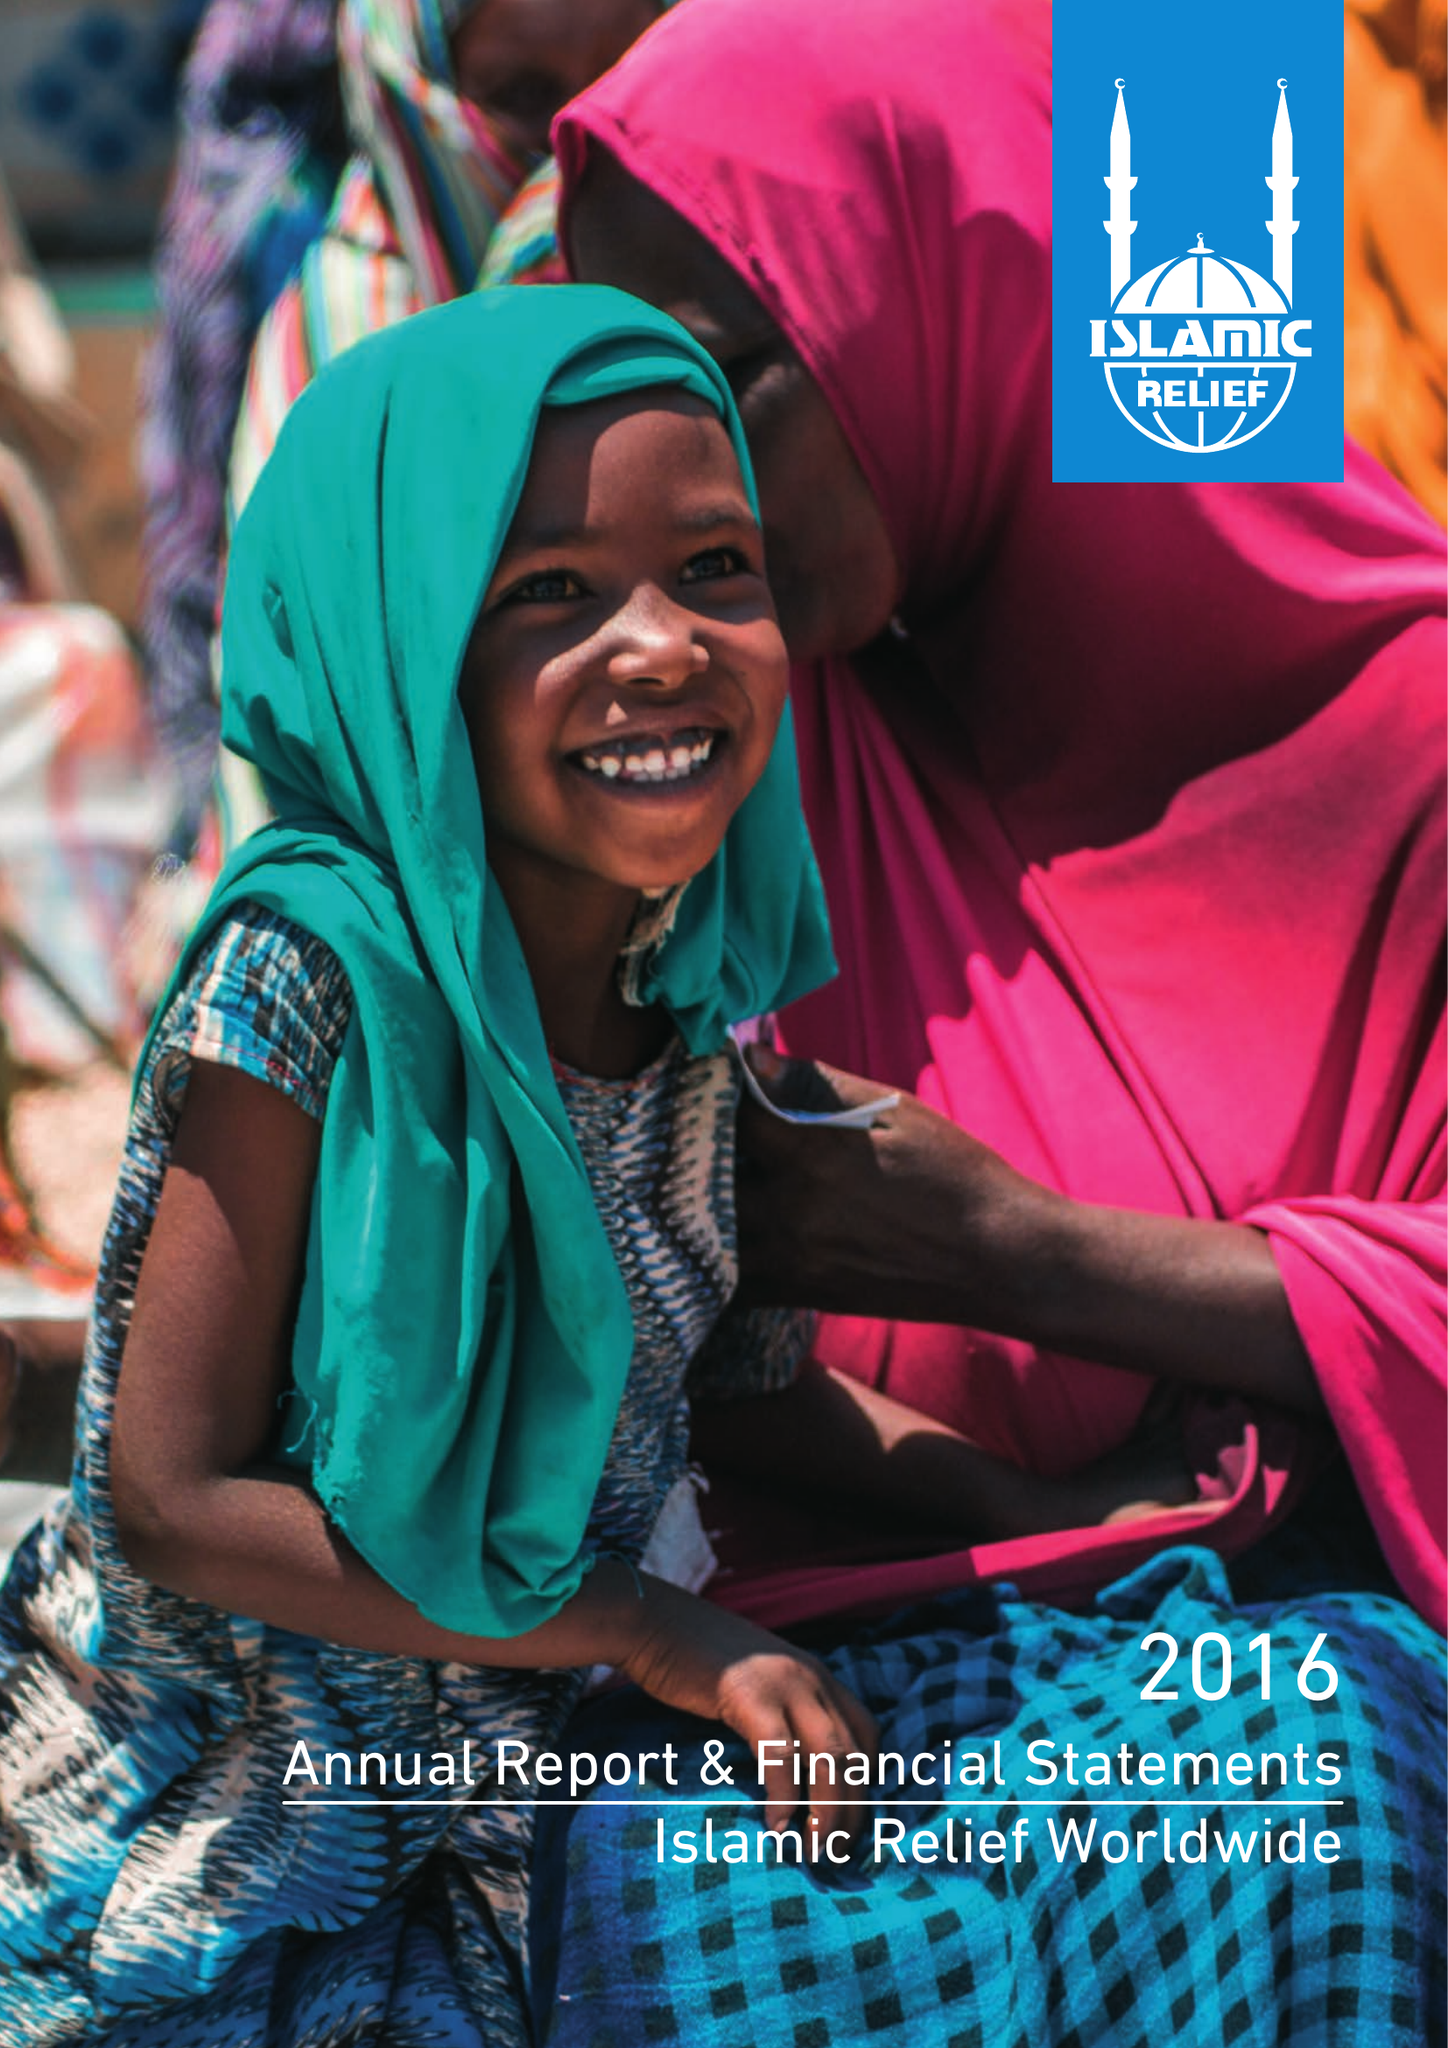What is the value for the address__postcode?
Answer the question using a single word or phrase. B5 6LB 